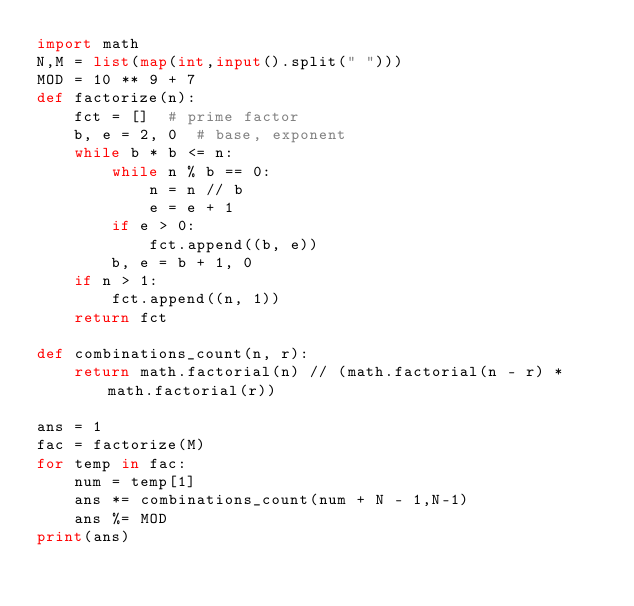<code> <loc_0><loc_0><loc_500><loc_500><_Python_>import math
N,M = list(map(int,input().split(" ")))
MOD = 10 ** 9 + 7
def factorize(n):
    fct = []  # prime factor
    b, e = 2, 0  # base, exponent
    while b * b <= n:
        while n % b == 0:
            n = n // b
            e = e + 1
        if e > 0:
            fct.append((b, e))
        b, e = b + 1, 0
    if n > 1:
        fct.append((n, 1))
    return fct

def combinations_count(n, r):
    return math.factorial(n) // (math.factorial(n - r) * math.factorial(r))

ans = 1
fac = factorize(M)
for temp in fac:
    num = temp[1]
    ans *= combinations_count(num + N - 1,N-1)
    ans %= MOD
print(ans)
</code> 